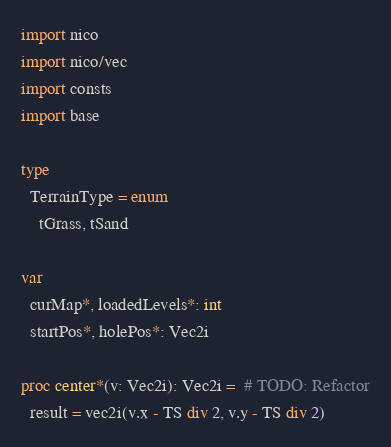<code> <loc_0><loc_0><loc_500><loc_500><_Nim_>import nico
import nico/vec
import consts
import base

type
  TerrainType = enum
    tGrass, tSand

var
  curMap*, loadedLevels*: int
  startPos*, holePos*: Vec2i

proc center*(v: Vec2i): Vec2i =  # TODO: Refactor
  result = vec2i(v.x - TS div 2, v.y - TS div 2)
</code> 